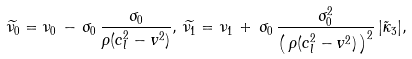<formula> <loc_0><loc_0><loc_500><loc_500>\widetilde { \nu _ { 0 } } = \nu _ { 0 } \, - \, \sigma _ { 0 } \, \frac { \sigma _ { 0 } } { \rho ( c _ { l } ^ { 2 } - v ^ { 2 } ) } , \, \widetilde { \nu _ { 1 } } = \nu _ { 1 } \, + \, \sigma _ { 0 } \, \frac { \sigma _ { 0 } ^ { 2 } } { \left ( \, \rho ( c _ { l } ^ { 2 } - v ^ { 2 } ) \, \right ) ^ { 2 } } \, | \tilde { \kappa } _ { 3 } | ,</formula> 